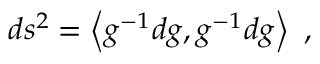Convert formula to latex. <formula><loc_0><loc_0><loc_500><loc_500>d s ^ { 2 } = \left < g ^ { - 1 } d g , g ^ { - 1 } d g \right > ,</formula> 